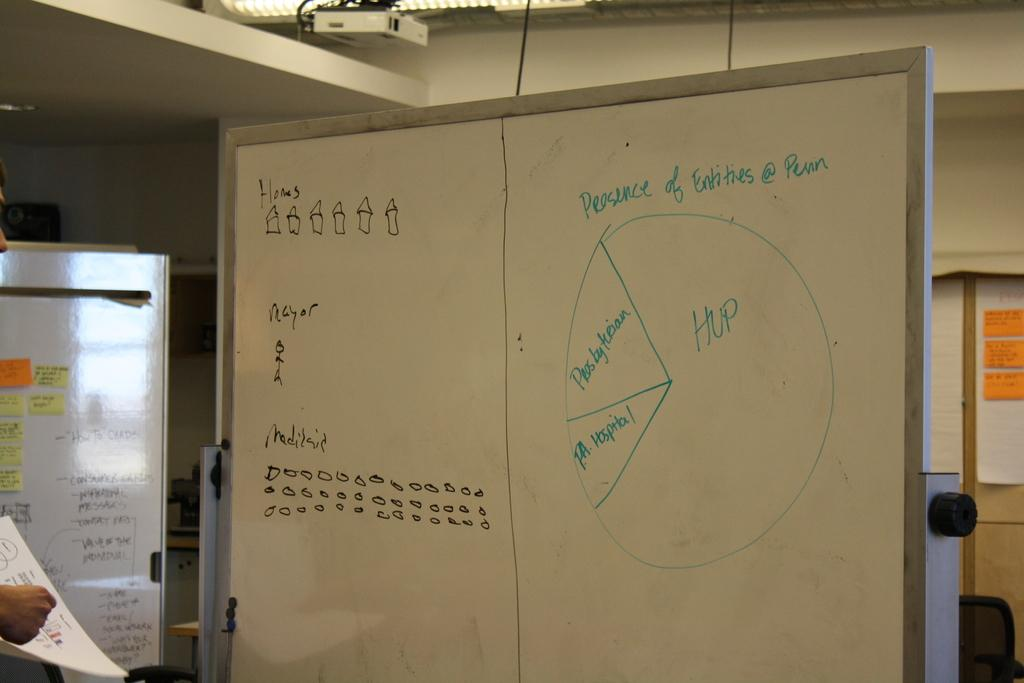<image>
Render a clear and concise summary of the photo. An office white board with little pictures of houses drawn on it and the word Homes above them. 